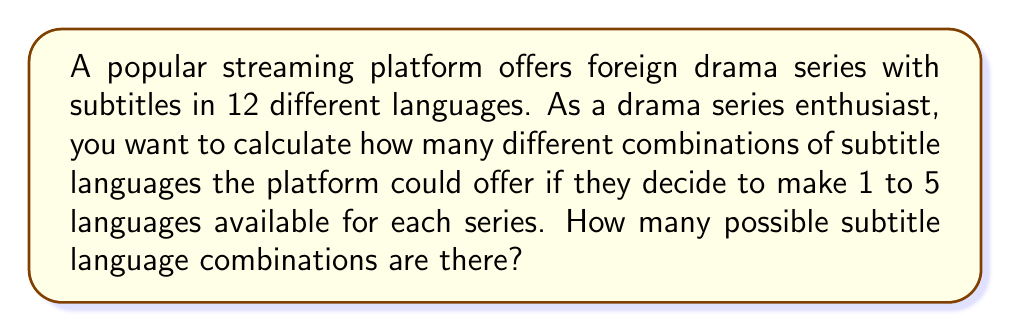Could you help me with this problem? Let's approach this step-by-step:

1) We need to calculate the number of combinations for each possible number of languages (1 to 5) and then sum them up.

2) For each case, we're selecting r languages from a total of 12 languages, where r ranges from 1 to 5. This is a combination problem.

3) The formula for combinations is:

   $$C(n,r) = \binom{n}{r} = \frac{n!}{r!(n-r)!}$$

   where n is the total number of items (12 languages) and r is the number of items being chosen.

4) Let's calculate each combination:

   For 1 language: $C(12,1) = \binom{12}{1} = 12$
   For 2 languages: $C(12,2) = \binom{12}{2} = 66$
   For 3 languages: $C(12,3) = \binom{12}{3} = 220$
   For 4 languages: $C(12,4) = \binom{12}{4} = 495$
   For 5 languages: $C(12,5) = \binom{12}{5} = 792$

5) The total number of possible combinations is the sum of all these:

   $12 + 66 + 220 + 495 + 792 = 1585$

Therefore, there are 1585 possible subtitle language combinations.
Answer: 1585 